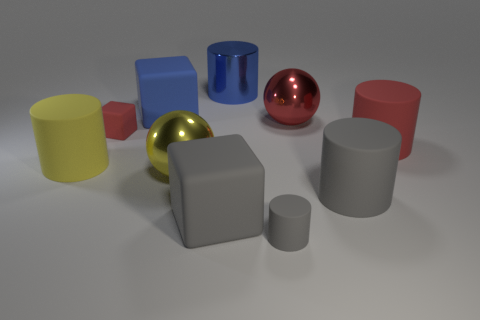Does the small block have the same color as the metal cylinder?
Make the answer very short. No. What is the material of the cylinder that is the same color as the small matte block?
Your answer should be very brief. Rubber. Is there any other thing that is the same shape as the tiny gray matte object?
Your response must be concise. Yes. What is the material of the small thing behind the tiny gray object?
Make the answer very short. Rubber. Do the ball that is to the left of the tiny gray matte object and the small red block have the same material?
Offer a very short reply. No. What number of objects are yellow cylinders or large things that are right of the big gray cylinder?
Provide a succinct answer. 2. There is a gray matte object that is the same shape as the blue matte thing; what is its size?
Ensure brevity in your answer.  Large. Are there any large matte cylinders to the left of the large metallic cylinder?
Provide a short and direct response. Yes. There is a ball in front of the yellow matte cylinder; is it the same color as the small rubber object that is behind the large yellow metal ball?
Provide a succinct answer. No. Is there a tiny yellow metallic thing of the same shape as the large red metallic thing?
Provide a short and direct response. No. 